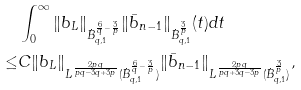Convert formula to latex. <formula><loc_0><loc_0><loc_500><loc_500>& \int _ { 0 } ^ { \infty } \| b _ { L } \| _ { \dot { B } ^ { \frac { 6 } { q } - \frac { 3 } { p } } _ { q , 1 } } \| \bar { b } _ { n - 1 } \| _ { \dot { B } ^ { \frac { 3 } { p } } _ { q , 1 } } ( t ) d t \\ \leq & C \| b _ { L } \| _ { L ^ { \frac { 2 p q } { p q - 3 q + 3 p } } ( \dot { B } ^ { \frac { 6 } { q } - \frac { 3 } { p } } _ { q , 1 } ) } \| \bar { b } _ { n - 1 } \| _ { L ^ { \frac { 2 p q } { p q + 3 q - 3 p } } ( \dot { B } ^ { \frac { 3 } { p } } _ { q , 1 } ) } ,</formula> 